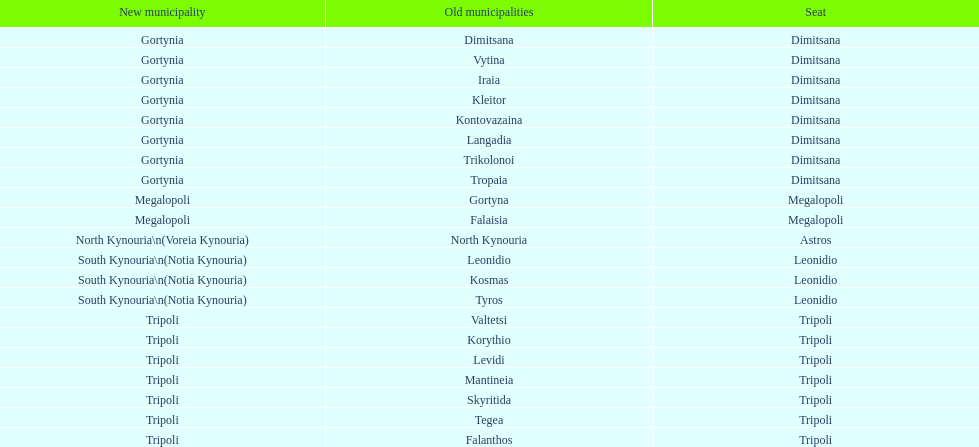What is the recent municipality of tyros? South Kynouria. 